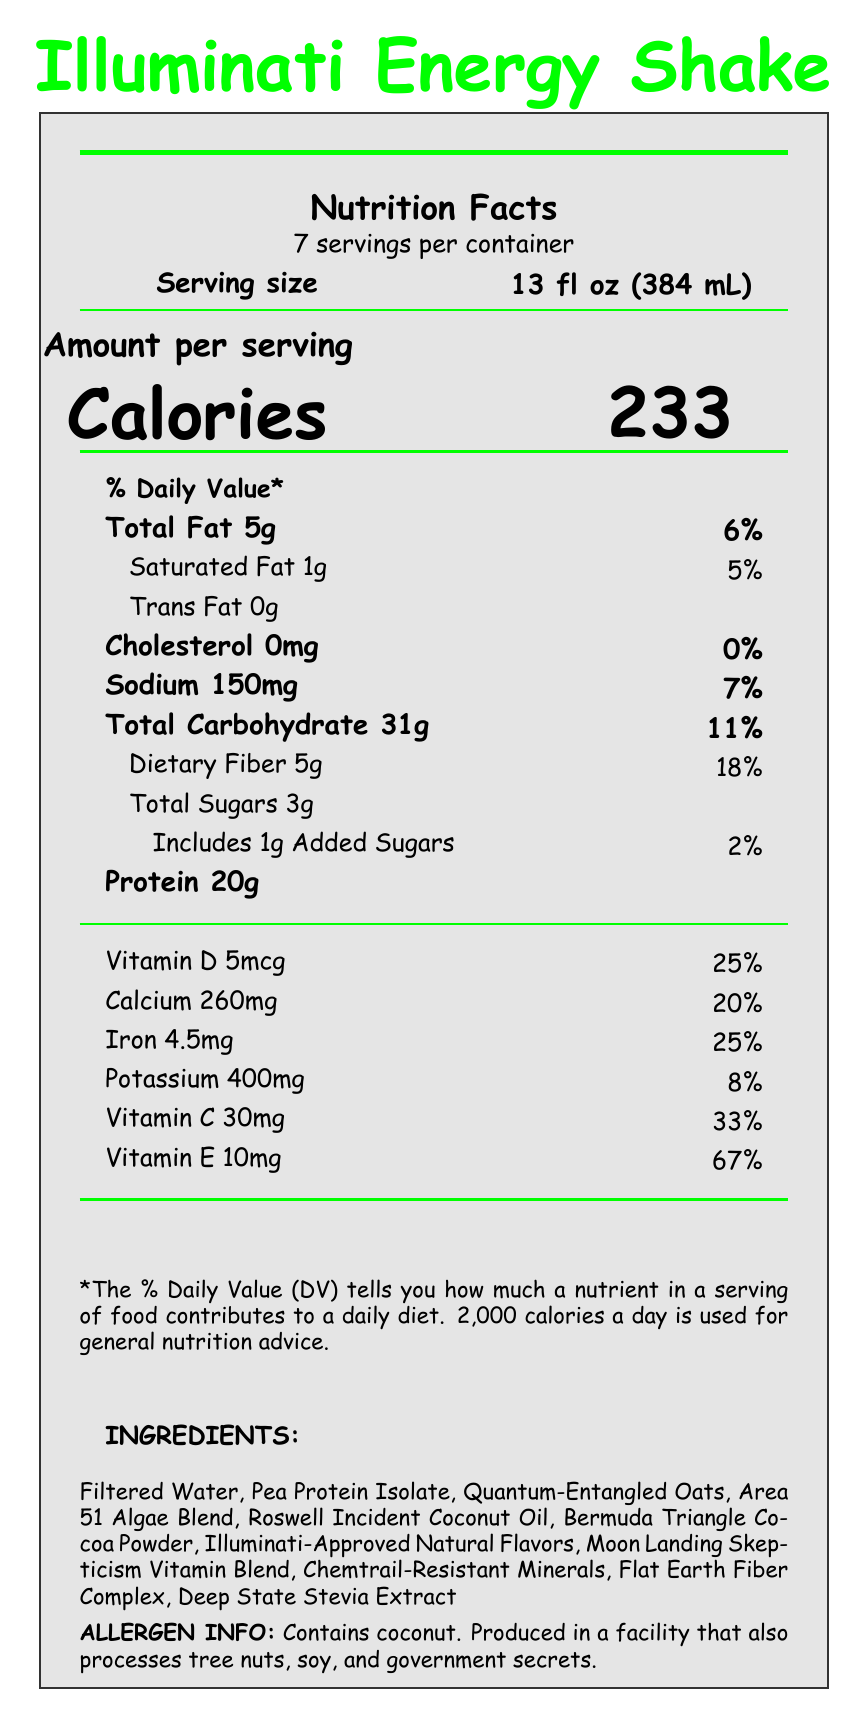what is the serving size of the Illuminati Energy Shake? The serving size is clearly listed at the top of the document next to the serving size label.
Answer: 13 fl oz (384 mL) how many calories are in one serving of the Illuminati Energy Shake? The calories per serving are prominently displayed in large font in the "Amount per serving" section.
Answer: 233 what are the total fats and their daily value percentage in one serving? The total fat amount and its daily value percentage are given in the nutrition facts section under "Total Fat".
Answer: 5g, 6% how many grams of protein are in one serving of the shake? The amount of protein per serving is listed under the nutrition facts, specifically under "Protein".
Answer: 20g how much calcium does one serving provide in terms of daily value percentage? The percentage of daily value for calcium is listed next to the calcium amount in the nutrition facts.
Answer: 20% does the Illuminati Energy Shake contain trans fat? Under the nutrition facts, it lists "Trans Fat 0g", indicating there is no trans fat in the shake.
Answer: No what is the serving size in terms of milliliters? A. 300 mL B. 320 mL C. 384 mL D. 400 mL The serving size in milliliters is listed as 384 mL next to the serving size label.
Answer: C. 384 mL which ingredient is NOT found in the Illuminati Energy Shake? A. Filtered Water B. Quantum-Entangled Oats C. GMO Corn Syrup D. Roswell Incident Coconut Oil The list of ingredients provided does not include GMO Corn Syrup, while the other options are listed.
Answer: C. GMO Corn Syrup is the Illuminati Energy Shake suitable for someone with a coconut allergy? The allergen information clearly mentions that the product contains coconut.
Answer: No describe the main idea of the document The document is formatted as a nutrition label, giving detailed data about serving size, nutritional content, ingredients, and includes entertaining conspiracy and gaming related elements.
Answer: The main idea of the document is to provide nutritional information, ingredient list, allergen warnings, and some playful 'conspiracy facts' and 'gaming Easter eggs' about the "Illuminati Energy Shake". how is the conspiracy theme represented in the ingredients list? The ingredients list includes names that reference popular conspiracy theories, adding a humorous twist to the product's theme.
Answer: Through amusing names like "Quantum-Entangled Oats", "Area 51 Algae Blend", and "Deep State Stevia Extract". how many servings per container does the Illuminati Energy Shake have? The number of servings per container is specified at the top of the document under "7 servings per container".
Answer: 7 can you determine the manufacturing location from this document? The document does not provide information about the manufacturing location.
Answer: Cannot be determined what is the percentage of daily value for Vitamin E in this shake? The percentage of daily value for Vitamin E is listed next to its amount in the nutrition facts section.
Answer: 67% 